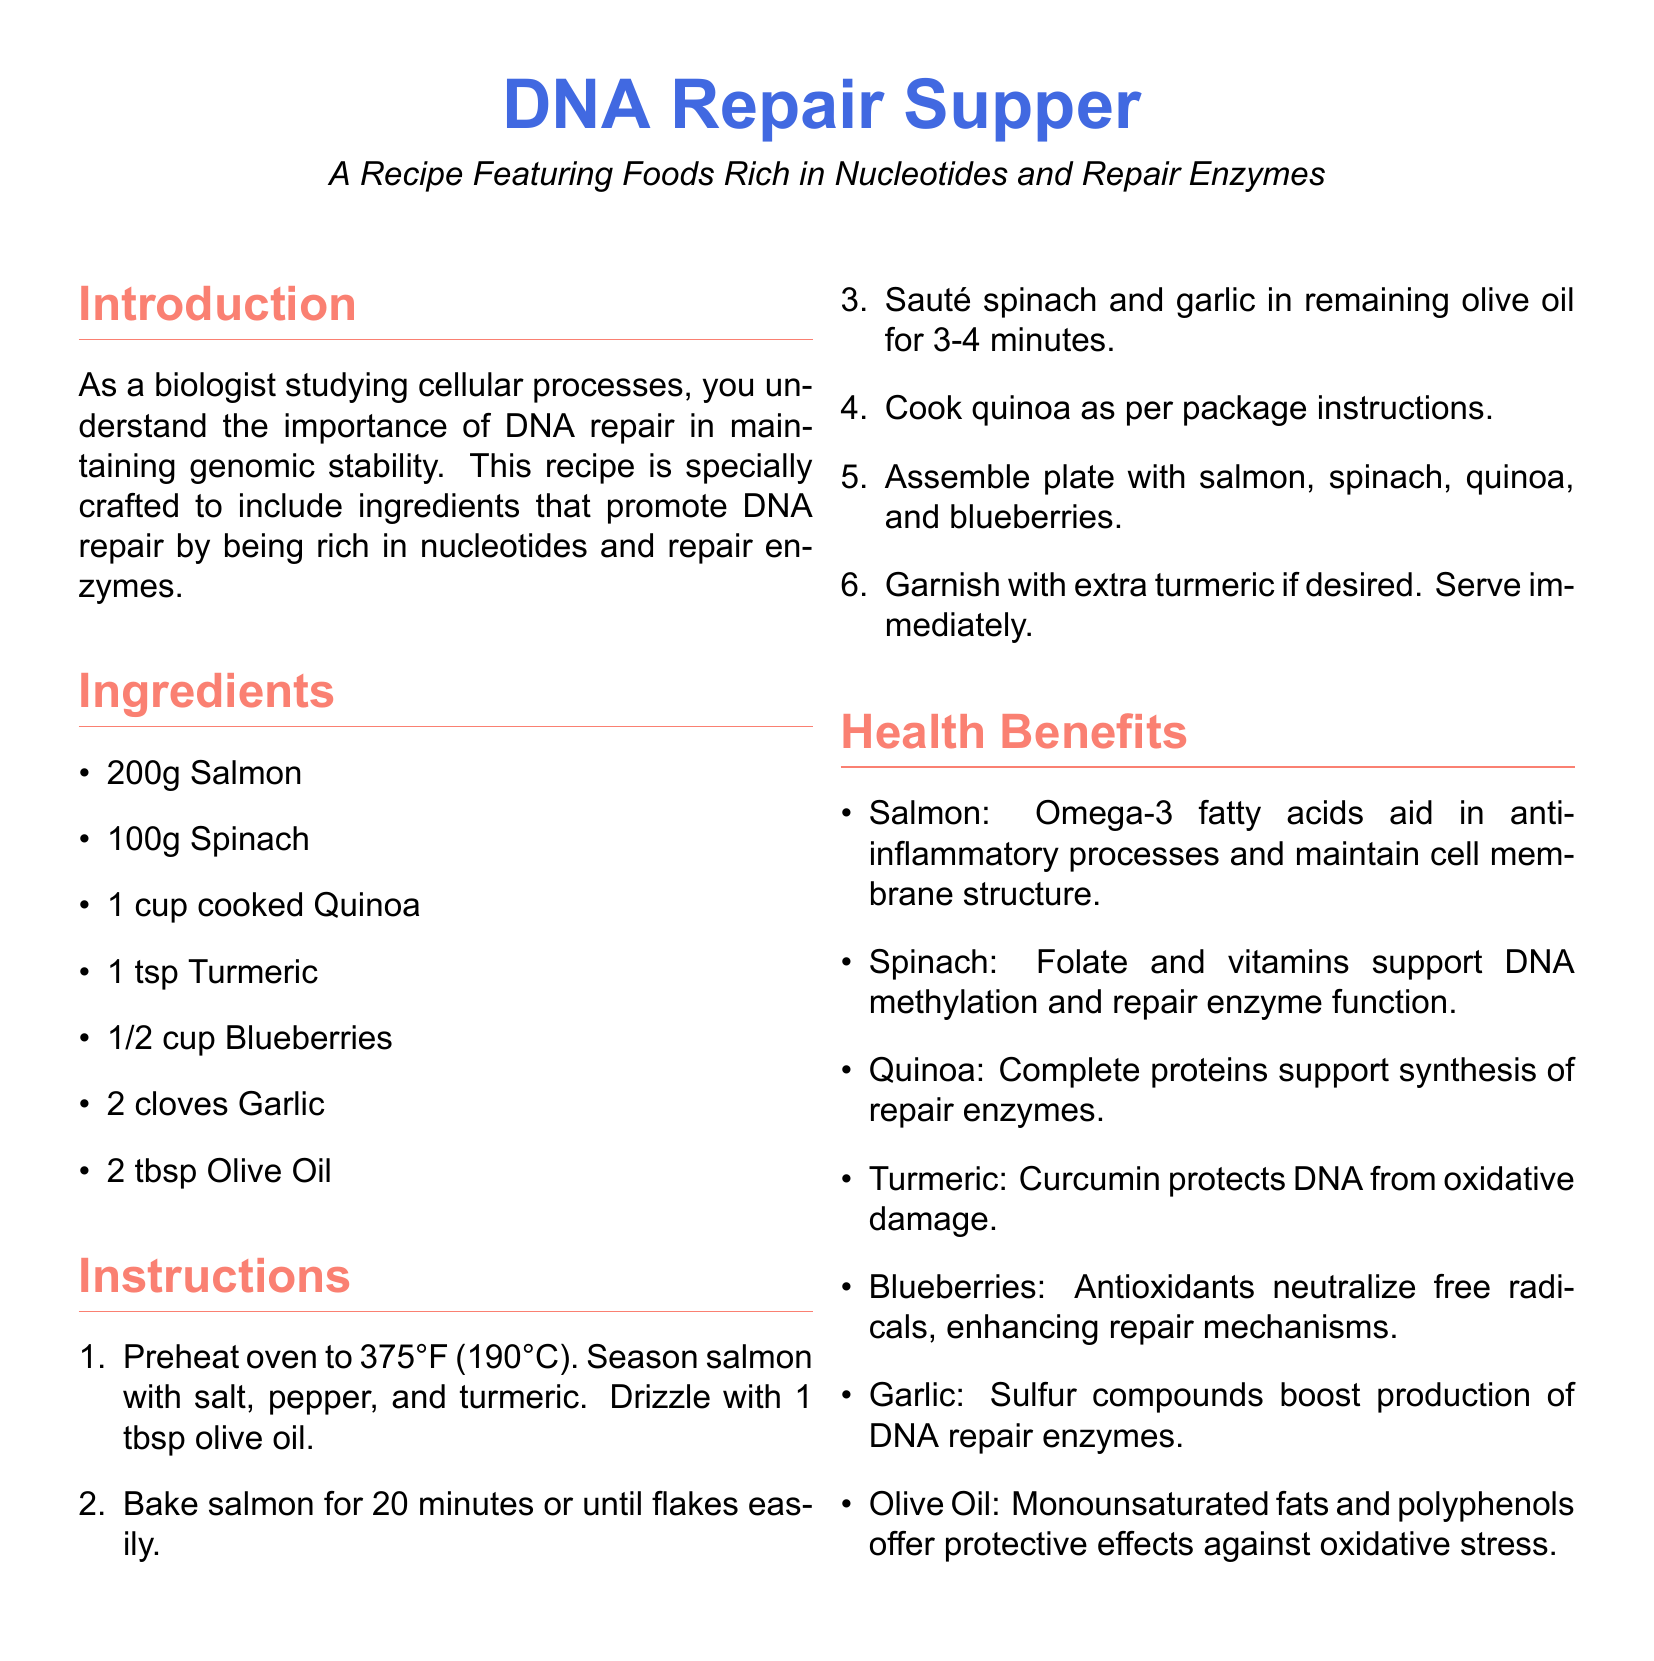what is the main title of the recipe? The main title of the recipe is located at the top of the document.
Answer: DNA Repair Supper how many cloves of garlic are used in the recipe? The number of garlic cloves is specified in the list of ingredients.
Answer: 2 cloves what is the cooking temperature for the salmon? The cooking temperature for the salmon is mentioned in the instructions section.
Answer: 375°F (190°C) which ingredient provides complete proteins for enzyme synthesis? The ingredient that supports enzyme synthesis is listed in the health benefits section.
Answer: Quinoa what color is used for the main title text? The color for the main title is specified in the document preamble.
Answer: blueberry blue why is turmeric included in the recipe? The reason for including turmeric is provided in the health benefits section.
Answer: Protects DNA from oxidative damage how long should the salmon be baked? The baking duration for the salmon is found in the instructions section.
Answer: 20 minutes which ingredient is an antioxidant? The ingredient that acts as an antioxidant is mentioned in the health benefits section.
Answer: Blueberries how is spinach prepared in the recipe? The method of preparing spinach is stated in the instructions section.
Answer: Sautéed with garlic what type of oil is used in the cooking process? The type of oil is mentioned in the list of ingredients.
Answer: Olive Oil 